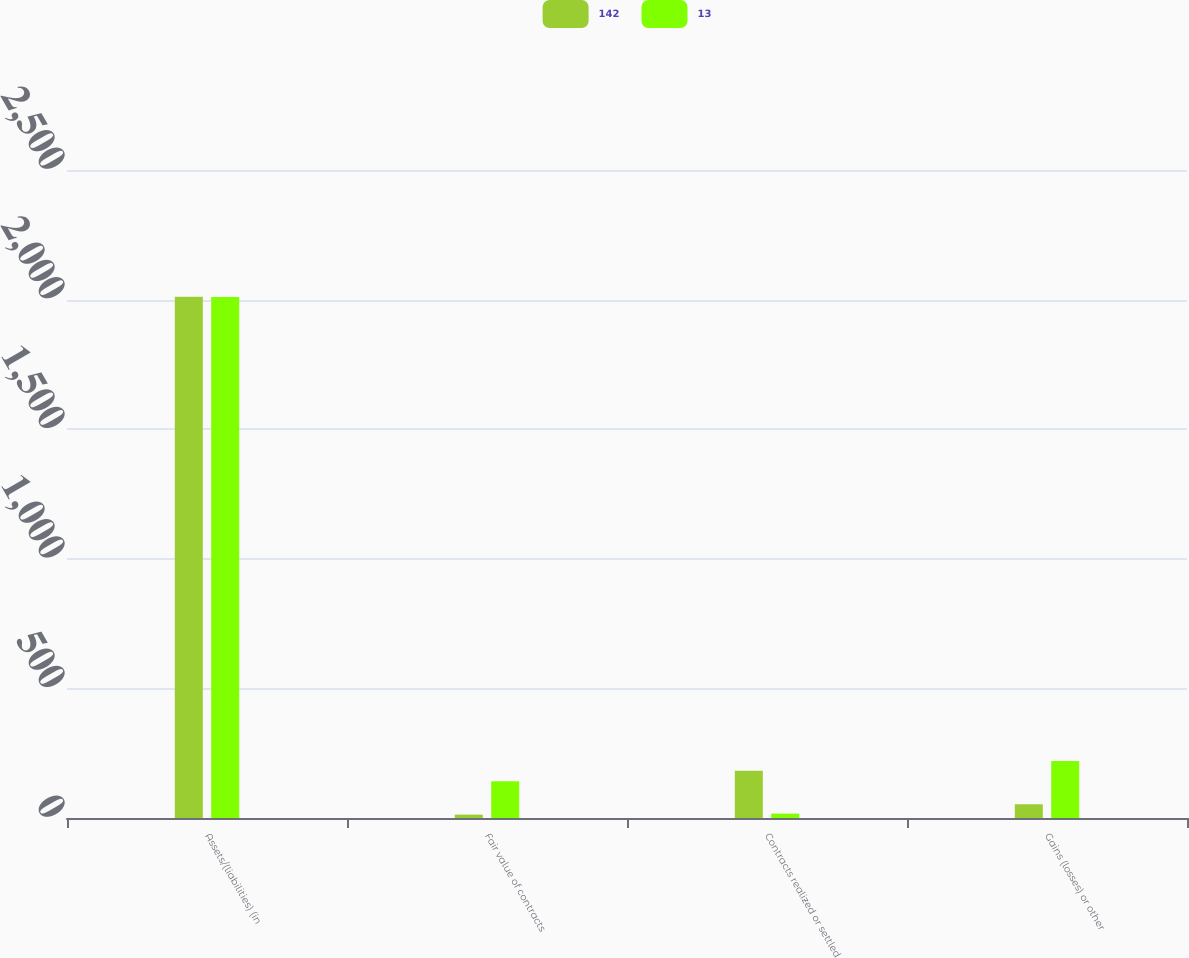<chart> <loc_0><loc_0><loc_500><loc_500><stacked_bar_chart><ecel><fcel>Assets/(liabilities) (in<fcel>Fair value of contracts<fcel>Contracts realized or settled<fcel>Gains (losses) or other<nl><fcel>142<fcel>2011<fcel>13<fcel>182<fcel>53<nl><fcel>13<fcel>2010<fcel>142<fcel>17<fcel>220<nl></chart> 